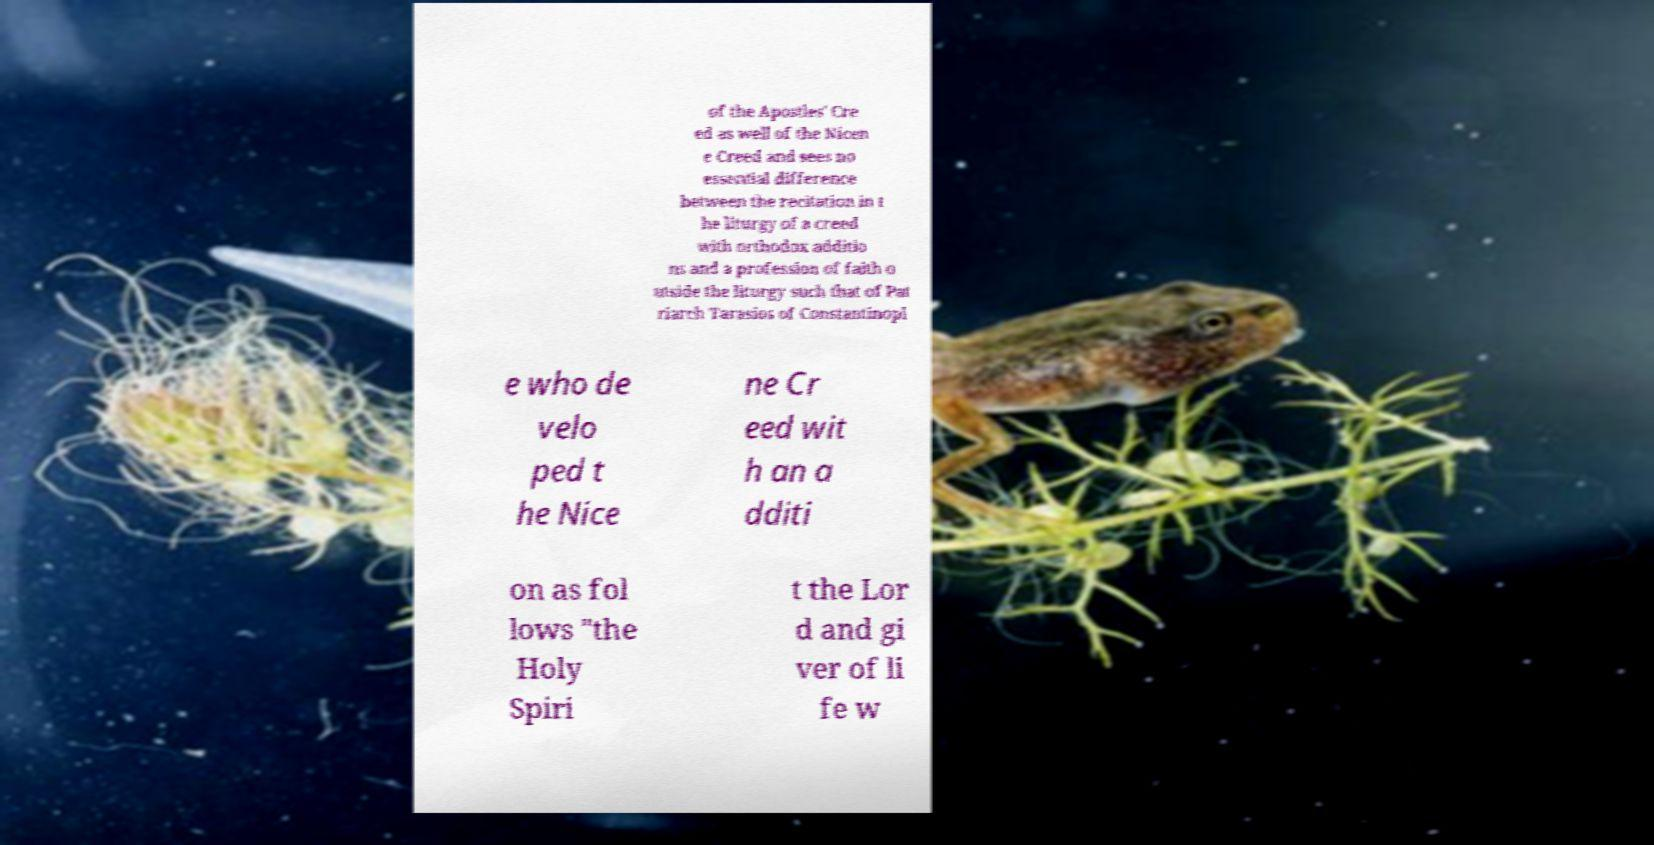There's text embedded in this image that I need extracted. Can you transcribe it verbatim? of the Apostles' Cre ed as well of the Nicen e Creed and sees no essential difference between the recitation in t he liturgy of a creed with orthodox additio ns and a profession of faith o utside the liturgy such that of Pat riarch Tarasios of Constantinopl e who de velo ped t he Nice ne Cr eed wit h an a dditi on as fol lows "the Holy Spiri t the Lor d and gi ver of li fe w 